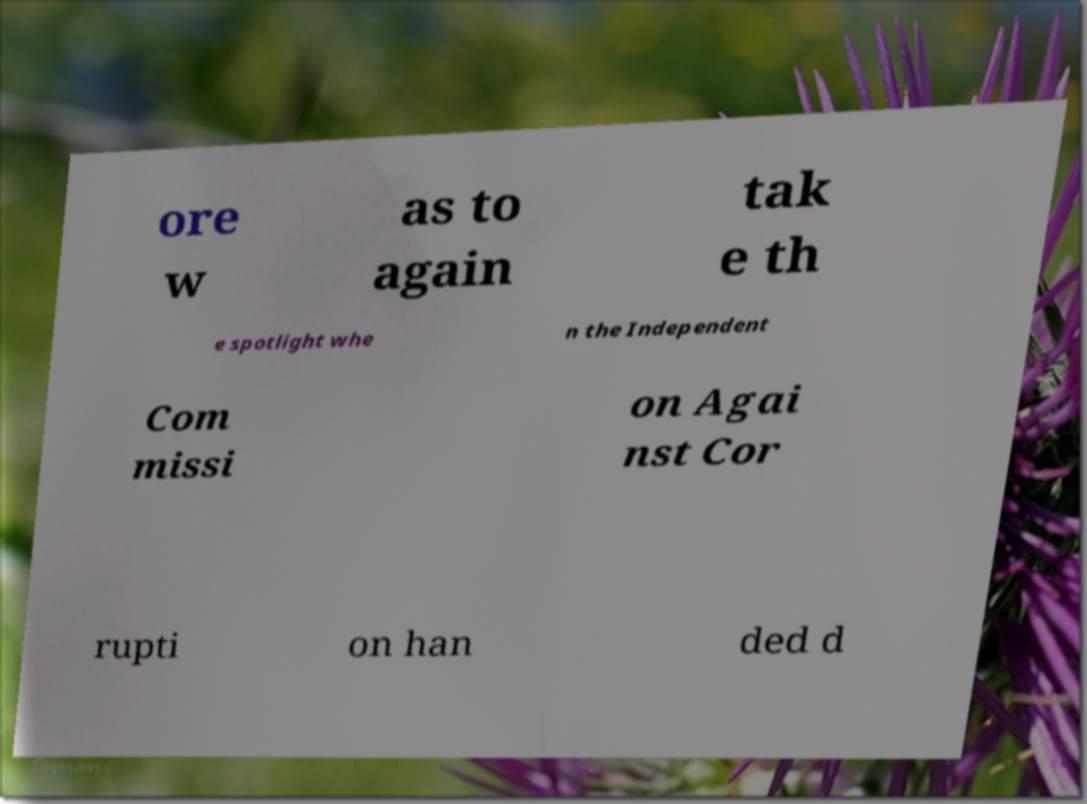Could you assist in decoding the text presented in this image and type it out clearly? ore w as to again tak e th e spotlight whe n the Independent Com missi on Agai nst Cor rupti on han ded d 